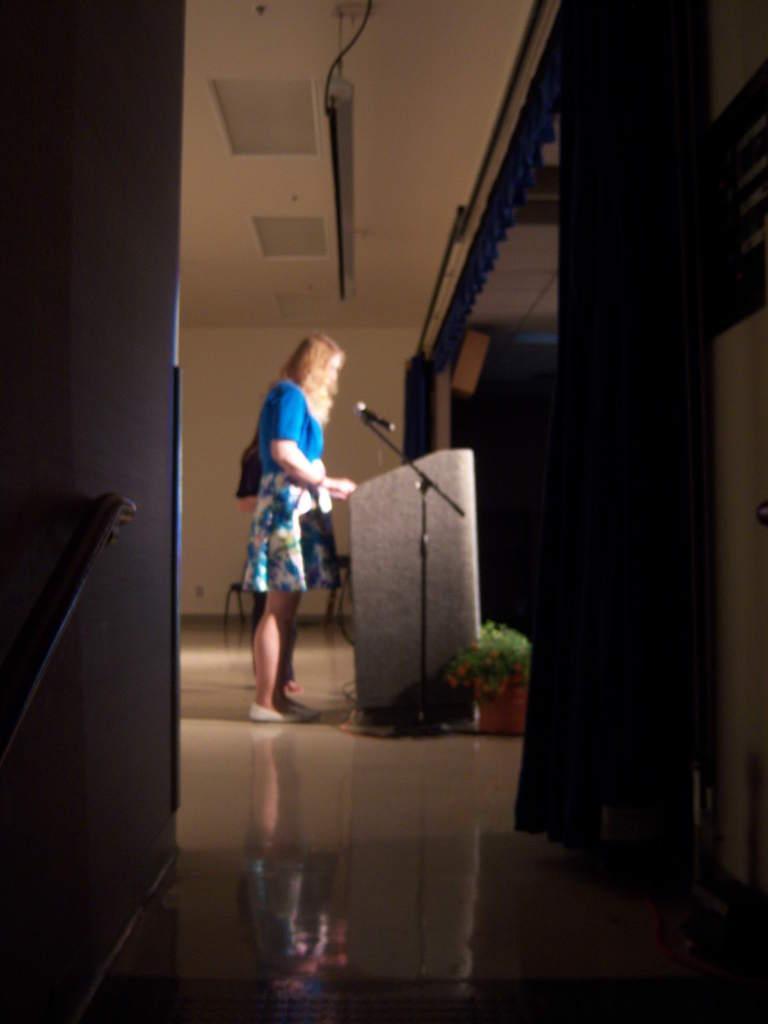How would you summarize this image in a sentence or two? In this image we can see a woman wearing blue dressing is standing on the floor in front of a podium beside it we can see a microphone placed on the stand. To the right side of the image we can see a plant. In the background, we can see a curtain and a metal rod. 